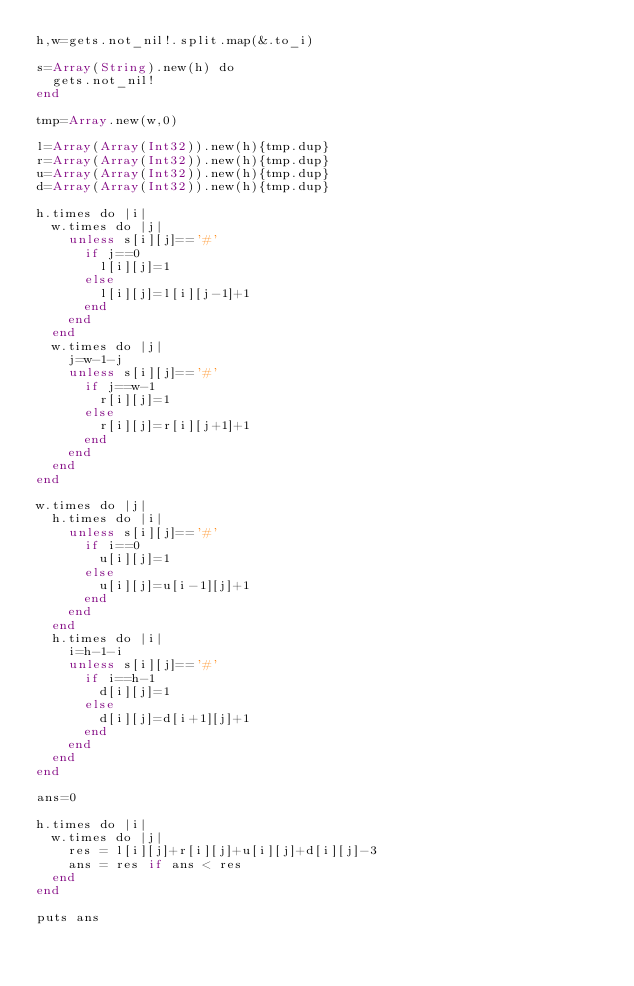Convert code to text. <code><loc_0><loc_0><loc_500><loc_500><_Crystal_>h,w=gets.not_nil!.split.map(&.to_i)

s=Array(String).new(h) do
  gets.not_nil!
end

tmp=Array.new(w,0)

l=Array(Array(Int32)).new(h){tmp.dup}
r=Array(Array(Int32)).new(h){tmp.dup}
u=Array(Array(Int32)).new(h){tmp.dup}
d=Array(Array(Int32)).new(h){tmp.dup}

h.times do |i|
  w.times do |j|
    unless s[i][j]=='#'
      if j==0
        l[i][j]=1
      else
        l[i][j]=l[i][j-1]+1
      end
    end
  end
  w.times do |j|
    j=w-1-j
    unless s[i][j]=='#'
      if j==w-1
        r[i][j]=1
      else
        r[i][j]=r[i][j+1]+1
      end
    end
  end
end

w.times do |j|
  h.times do |i|
    unless s[i][j]=='#'
      if i==0
        u[i][j]=1
      else
        u[i][j]=u[i-1][j]+1
      end
    end
  end
  h.times do |i|
    i=h-1-i
    unless s[i][j]=='#'
      if i==h-1
        d[i][j]=1
      else
        d[i][j]=d[i+1][j]+1
      end
    end
  end
end

ans=0

h.times do |i|
  w.times do |j|
    res = l[i][j]+r[i][j]+u[i][j]+d[i][j]-3
    ans = res if ans < res
  end
end

puts ans
</code> 